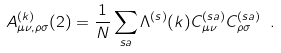Convert formula to latex. <formula><loc_0><loc_0><loc_500><loc_500>A ^ { ( k ) } _ { \mu \nu , \rho \sigma } ( 2 ) = \frac { 1 } { N } \sum _ { s a } \Lambda ^ { ( s ) } ( k ) C ^ { ( s a ) } _ { \mu \nu } C ^ { ( s a ) } _ { \rho \sigma } \ .</formula> 